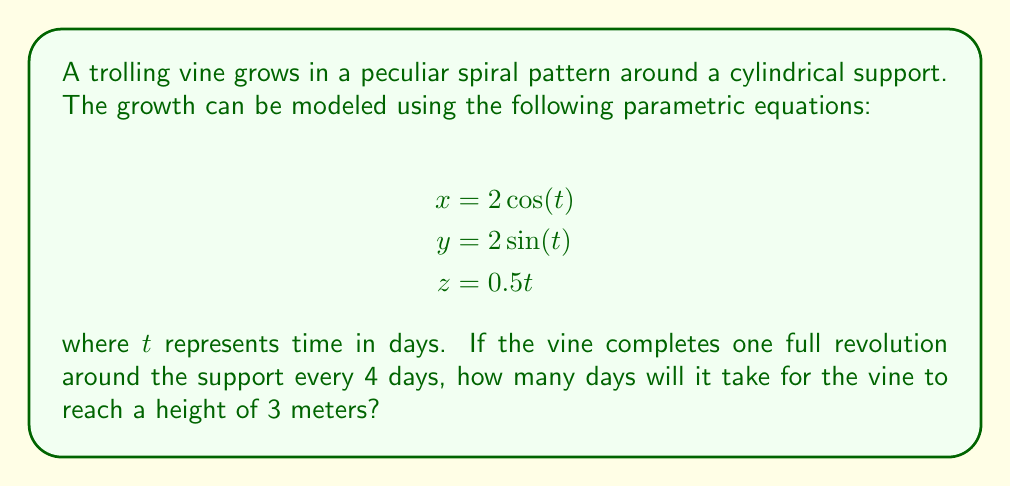Solve this math problem. To solve this problem, we need to follow these steps:

1. Understand the given parametric equations:
   - $x = 2\cos(t)$ and $y = 2\sin(t)$ describe the circular motion around the support
   - $z = 0.5t$ describes the vertical growth

2. Determine the period of one revolution:
   - One full revolution occurs every 4 days
   - This means that $2\pi$ radians in the $x$-$y$ plane correspond to 4 days
   - We can express this as: $t = 4$ when $\theta = 2\pi$

3. Find the relationship between $t$ and $\theta$:
   $$\frac{t}{4} = \frac{\theta}{2\pi}$$
   $$t = \frac{4\theta}{2\pi} = \frac{2\theta}{\pi}$$

4. Substitute this relationship into the equation for $z$:
   $$z = 0.5t = 0.5 \cdot \frac{2\theta}{\pi} = \frac{\theta}{\pi}$$

5. Find $\theta$ when $z = 3$ meters:
   $$3 = \frac{\theta}{\pi}$$
   $$\theta = 3\pi$$

6. Calculate the time $t$ when $z = 3$ meters:
   $$t = \frac{2\theta}{\pi} = \frac{2(3\pi)}{\pi} = 6\pi \approx 18.85$$

Therefore, it will take approximately 18.85 days for the trolling vine to reach a height of 3 meters.
Answer: $6\pi$ days or approximately 18.85 days 